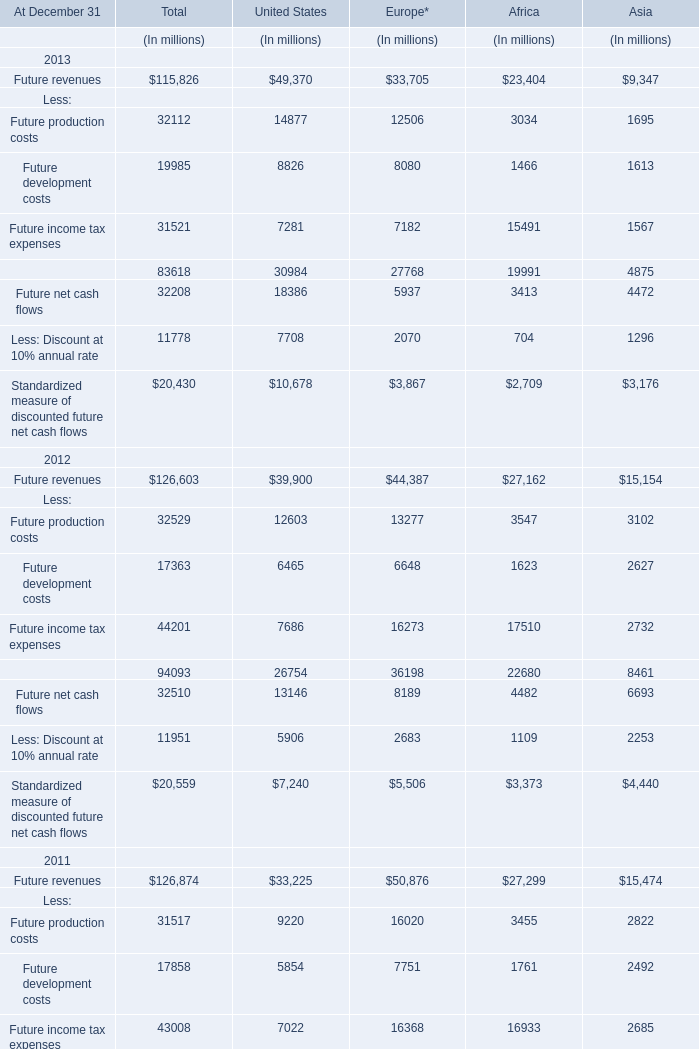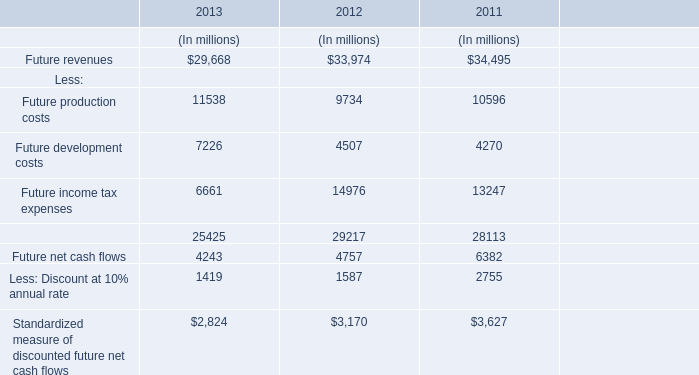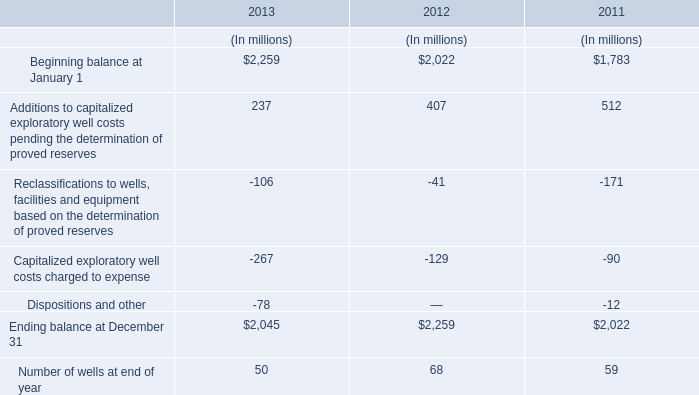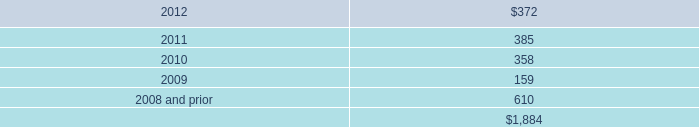Which year is Future income tax expenses the highest? 
Answer: 2012. 